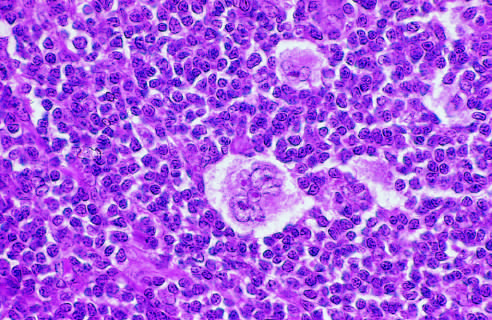s paler trabeculae seen lying within a clear space created by retraction of its cytoplasms?
Answer the question using a single word or phrase. No 